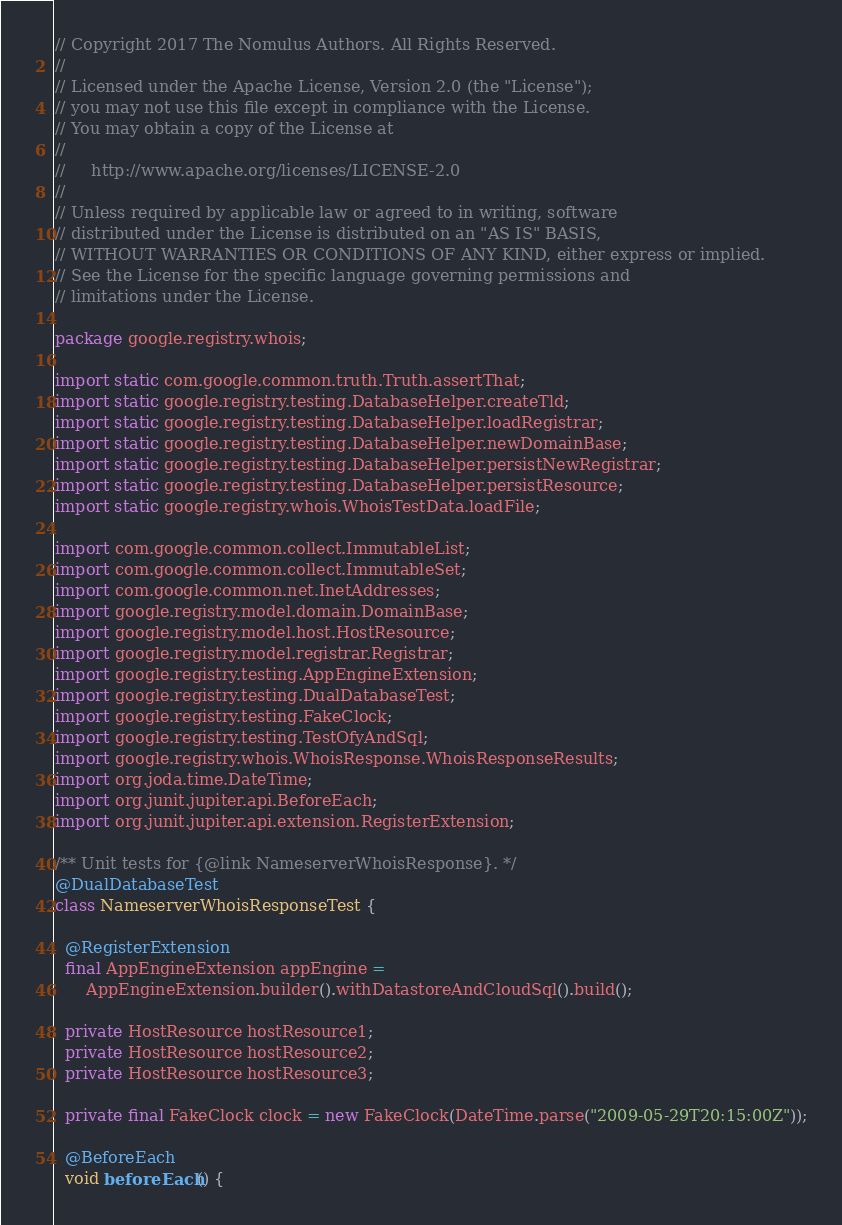Convert code to text. <code><loc_0><loc_0><loc_500><loc_500><_Java_>// Copyright 2017 The Nomulus Authors. All Rights Reserved.
//
// Licensed under the Apache License, Version 2.0 (the "License");
// you may not use this file except in compliance with the License.
// You may obtain a copy of the License at
//
//     http://www.apache.org/licenses/LICENSE-2.0
//
// Unless required by applicable law or agreed to in writing, software
// distributed under the License is distributed on an "AS IS" BASIS,
// WITHOUT WARRANTIES OR CONDITIONS OF ANY KIND, either express or implied.
// See the License for the specific language governing permissions and
// limitations under the License.

package google.registry.whois;

import static com.google.common.truth.Truth.assertThat;
import static google.registry.testing.DatabaseHelper.createTld;
import static google.registry.testing.DatabaseHelper.loadRegistrar;
import static google.registry.testing.DatabaseHelper.newDomainBase;
import static google.registry.testing.DatabaseHelper.persistNewRegistrar;
import static google.registry.testing.DatabaseHelper.persistResource;
import static google.registry.whois.WhoisTestData.loadFile;

import com.google.common.collect.ImmutableList;
import com.google.common.collect.ImmutableSet;
import com.google.common.net.InetAddresses;
import google.registry.model.domain.DomainBase;
import google.registry.model.host.HostResource;
import google.registry.model.registrar.Registrar;
import google.registry.testing.AppEngineExtension;
import google.registry.testing.DualDatabaseTest;
import google.registry.testing.FakeClock;
import google.registry.testing.TestOfyAndSql;
import google.registry.whois.WhoisResponse.WhoisResponseResults;
import org.joda.time.DateTime;
import org.junit.jupiter.api.BeforeEach;
import org.junit.jupiter.api.extension.RegisterExtension;

/** Unit tests for {@link NameserverWhoisResponse}. */
@DualDatabaseTest
class NameserverWhoisResponseTest {

  @RegisterExtension
  final AppEngineExtension appEngine =
      AppEngineExtension.builder().withDatastoreAndCloudSql().build();

  private HostResource hostResource1;
  private HostResource hostResource2;
  private HostResource hostResource3;

  private final FakeClock clock = new FakeClock(DateTime.parse("2009-05-29T20:15:00Z"));

  @BeforeEach
  void beforeEach() {</code> 